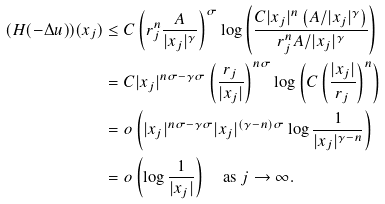Convert formula to latex. <formula><loc_0><loc_0><loc_500><loc_500>( H ( - \Delta u ) ) ( x _ { j } ) & \leq C \left ( r _ { j } ^ { n } \frac { A } { | x _ { j } | ^ { \gamma } } \right ) ^ { \sigma } \log \left ( \frac { C | x _ { j } | ^ { n } \left ( A / | x _ { j } | ^ { \gamma } \right ) } { r _ { j } ^ { n } A / | x _ { j } | ^ { \gamma } } \right ) \\ & = C | x _ { j } | ^ { n \sigma - \gamma \sigma } \left ( \frac { r _ { j } } { | x _ { j } | } \right ) ^ { n \sigma } \log \left ( C \left ( \frac { | x _ { j } | } { r _ { j } } \right ) ^ { n } \right ) \\ & = o \left ( | x _ { j } | ^ { n \sigma - \gamma \sigma } | x _ { j } | ^ { ( \gamma - n ) \sigma } \log \frac { 1 } { | x _ { j } | ^ { \gamma - n } } \right ) \\ & = o \left ( \log \frac { 1 } { | x _ { j } | } \right ) \quad \text {as } j \to \infty .</formula> 